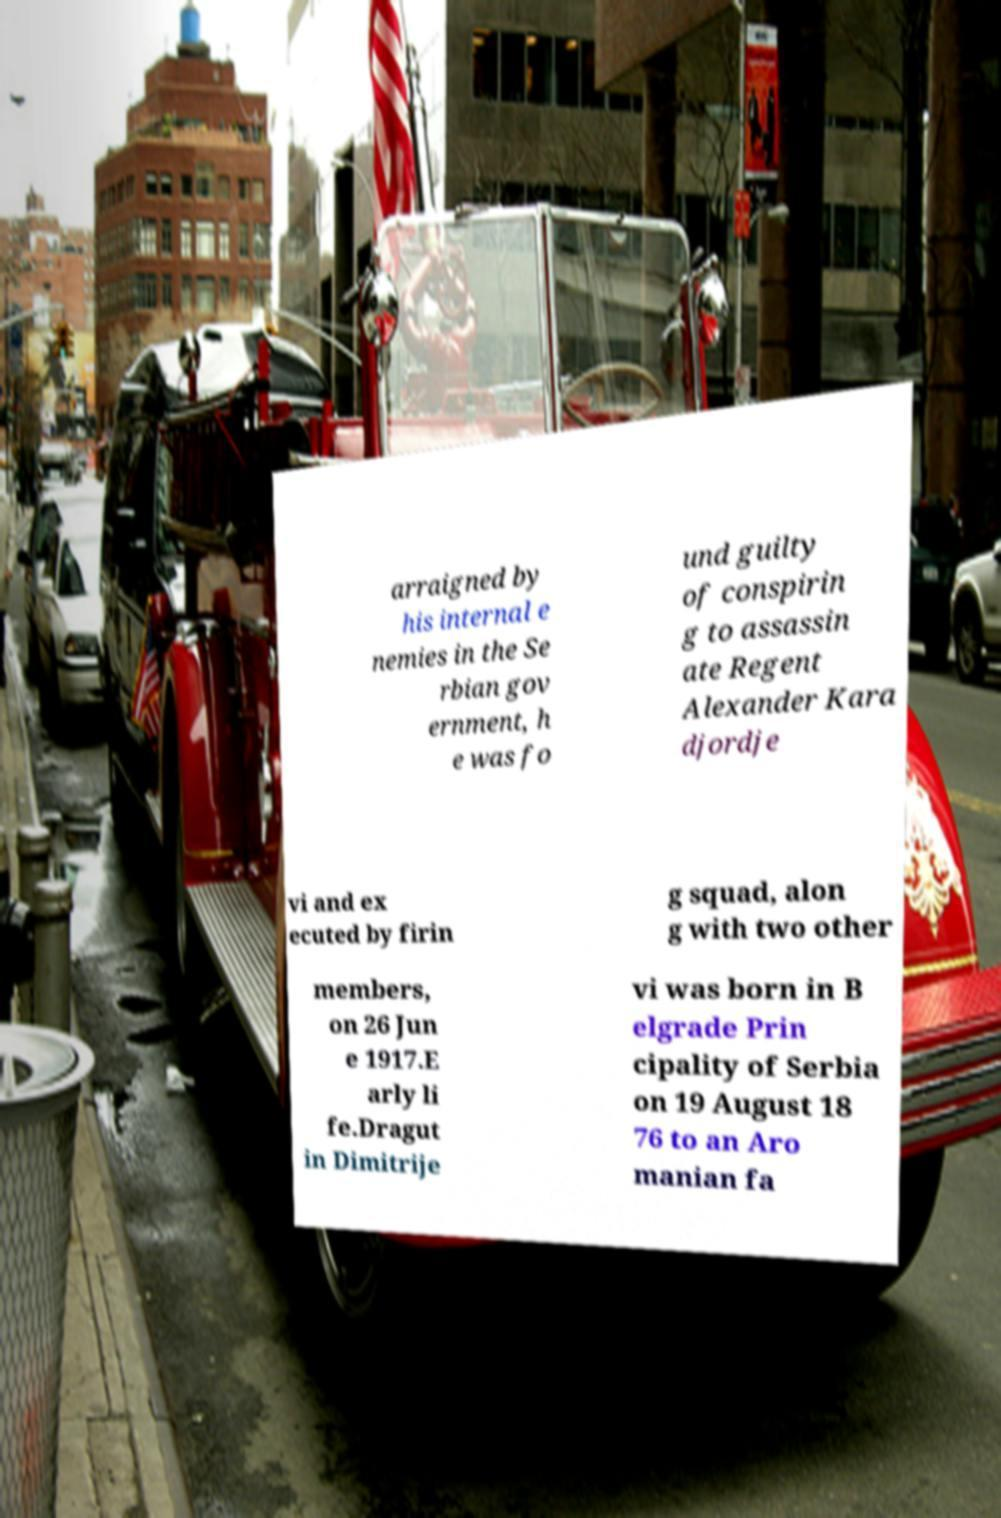Can you read and provide the text displayed in the image?This photo seems to have some interesting text. Can you extract and type it out for me? arraigned by his internal e nemies in the Se rbian gov ernment, h e was fo und guilty of conspirin g to assassin ate Regent Alexander Kara djordje vi and ex ecuted by firin g squad, alon g with two other members, on 26 Jun e 1917.E arly li fe.Dragut in Dimitrije vi was born in B elgrade Prin cipality of Serbia on 19 August 18 76 to an Aro manian fa 